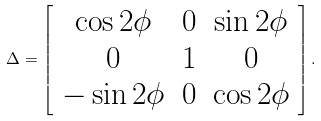Convert formula to latex. <formula><loc_0><loc_0><loc_500><loc_500>\Delta = \left [ \begin{array} { c c c } \cos 2 \phi & 0 & \sin 2 \phi \\ 0 & 1 & 0 \\ - \sin 2 \phi & 0 & \cos 2 \phi \end{array} \right ] .</formula> 